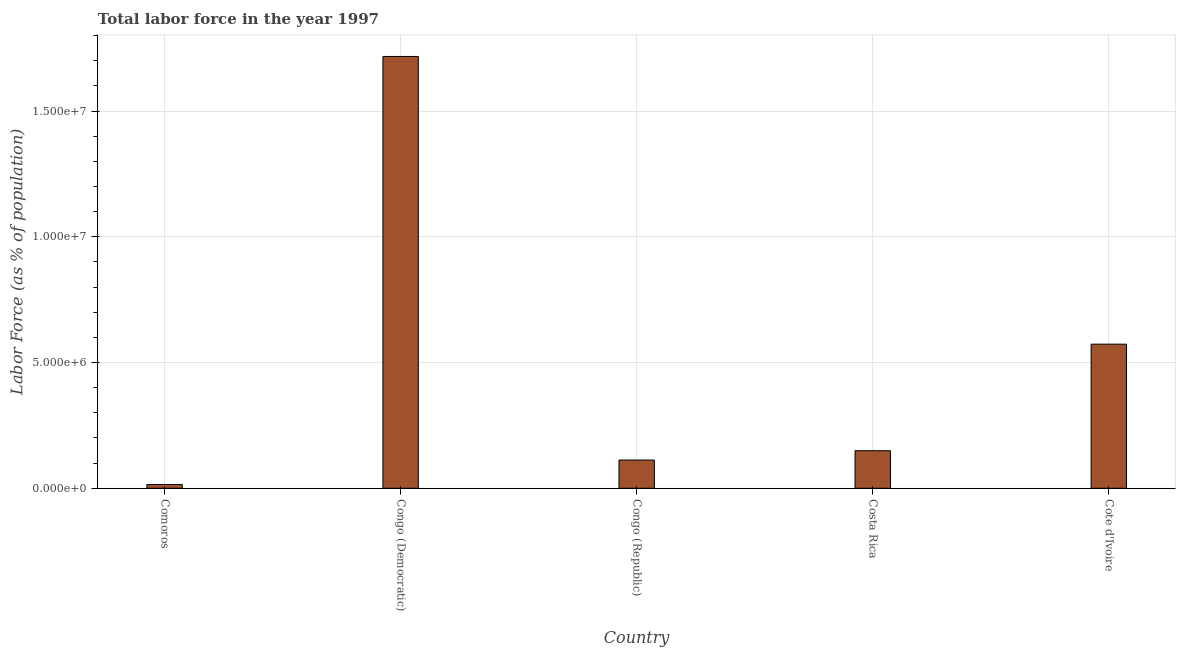Does the graph contain any zero values?
Offer a terse response. No. Does the graph contain grids?
Offer a very short reply. Yes. What is the title of the graph?
Your answer should be very brief. Total labor force in the year 1997. What is the label or title of the X-axis?
Give a very brief answer. Country. What is the label or title of the Y-axis?
Your response must be concise. Labor Force (as % of population). What is the total labor force in Comoros?
Your answer should be compact. 1.51e+05. Across all countries, what is the maximum total labor force?
Your response must be concise. 1.72e+07. Across all countries, what is the minimum total labor force?
Make the answer very short. 1.51e+05. In which country was the total labor force maximum?
Offer a terse response. Congo (Democratic). In which country was the total labor force minimum?
Give a very brief answer. Comoros. What is the sum of the total labor force?
Make the answer very short. 2.57e+07. What is the difference between the total labor force in Congo (Republic) and Costa Rica?
Offer a terse response. -3.71e+05. What is the average total labor force per country?
Provide a short and direct response. 5.13e+06. What is the median total labor force?
Make the answer very short. 1.49e+06. What is the ratio of the total labor force in Comoros to that in Cote d'Ivoire?
Your answer should be compact. 0.03. Is the total labor force in Comoros less than that in Cote d'Ivoire?
Ensure brevity in your answer.  Yes. What is the difference between the highest and the second highest total labor force?
Offer a terse response. 1.14e+07. What is the difference between the highest and the lowest total labor force?
Provide a short and direct response. 1.70e+07. How many bars are there?
Your response must be concise. 5. How many countries are there in the graph?
Give a very brief answer. 5. What is the difference between two consecutive major ticks on the Y-axis?
Provide a succinct answer. 5.00e+06. What is the Labor Force (as % of population) in Comoros?
Give a very brief answer. 1.51e+05. What is the Labor Force (as % of population) in Congo (Democratic)?
Ensure brevity in your answer.  1.72e+07. What is the Labor Force (as % of population) of Congo (Republic)?
Your response must be concise. 1.12e+06. What is the Labor Force (as % of population) in Costa Rica?
Offer a terse response. 1.49e+06. What is the Labor Force (as % of population) of Cote d'Ivoire?
Your answer should be very brief. 5.73e+06. What is the difference between the Labor Force (as % of population) in Comoros and Congo (Democratic)?
Offer a very short reply. -1.70e+07. What is the difference between the Labor Force (as % of population) in Comoros and Congo (Republic)?
Your response must be concise. -9.72e+05. What is the difference between the Labor Force (as % of population) in Comoros and Costa Rica?
Provide a short and direct response. -1.34e+06. What is the difference between the Labor Force (as % of population) in Comoros and Cote d'Ivoire?
Your answer should be very brief. -5.58e+06. What is the difference between the Labor Force (as % of population) in Congo (Democratic) and Congo (Republic)?
Keep it short and to the point. 1.60e+07. What is the difference between the Labor Force (as % of population) in Congo (Democratic) and Costa Rica?
Offer a very short reply. 1.57e+07. What is the difference between the Labor Force (as % of population) in Congo (Democratic) and Cote d'Ivoire?
Provide a succinct answer. 1.14e+07. What is the difference between the Labor Force (as % of population) in Congo (Republic) and Costa Rica?
Provide a short and direct response. -3.71e+05. What is the difference between the Labor Force (as % of population) in Congo (Republic) and Cote d'Ivoire?
Your answer should be compact. -4.61e+06. What is the difference between the Labor Force (as % of population) in Costa Rica and Cote d'Ivoire?
Your answer should be very brief. -4.24e+06. What is the ratio of the Labor Force (as % of population) in Comoros to that in Congo (Democratic)?
Provide a succinct answer. 0.01. What is the ratio of the Labor Force (as % of population) in Comoros to that in Congo (Republic)?
Make the answer very short. 0.14. What is the ratio of the Labor Force (as % of population) in Comoros to that in Costa Rica?
Ensure brevity in your answer.  0.1. What is the ratio of the Labor Force (as % of population) in Comoros to that in Cote d'Ivoire?
Make the answer very short. 0.03. What is the ratio of the Labor Force (as % of population) in Congo (Democratic) to that in Congo (Republic)?
Your response must be concise. 15.28. What is the ratio of the Labor Force (as % of population) in Congo (Democratic) to that in Costa Rica?
Provide a succinct answer. 11.49. What is the ratio of the Labor Force (as % of population) in Congo (Democratic) to that in Cote d'Ivoire?
Give a very brief answer. 3. What is the ratio of the Labor Force (as % of population) in Congo (Republic) to that in Costa Rica?
Ensure brevity in your answer.  0.75. What is the ratio of the Labor Force (as % of population) in Congo (Republic) to that in Cote d'Ivoire?
Offer a very short reply. 0.2. What is the ratio of the Labor Force (as % of population) in Costa Rica to that in Cote d'Ivoire?
Make the answer very short. 0.26. 